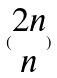<formula> <loc_0><loc_0><loc_500><loc_500>( \begin{matrix} 2 n \\ n \end{matrix} )</formula> 